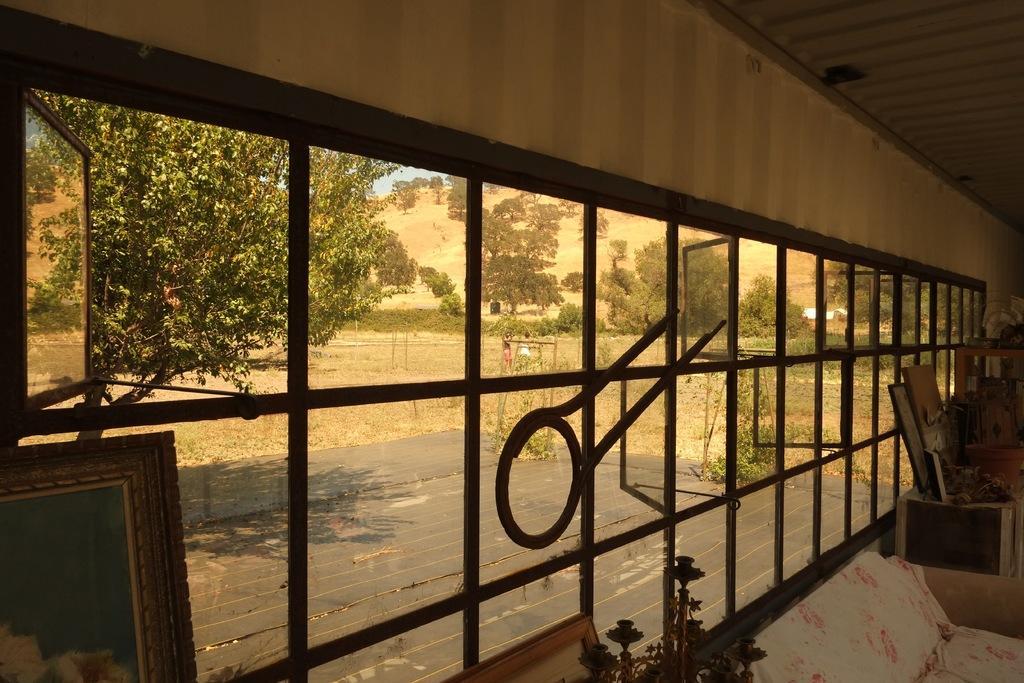Please provide a concise description of this image. In this image there is a wall for that wall there is a glass window through that window fields, trees and floor are visible, in the bottom right there is a sofa and other objects, in the top right there is a ceiling, in the bottom left there is a photo frame. 